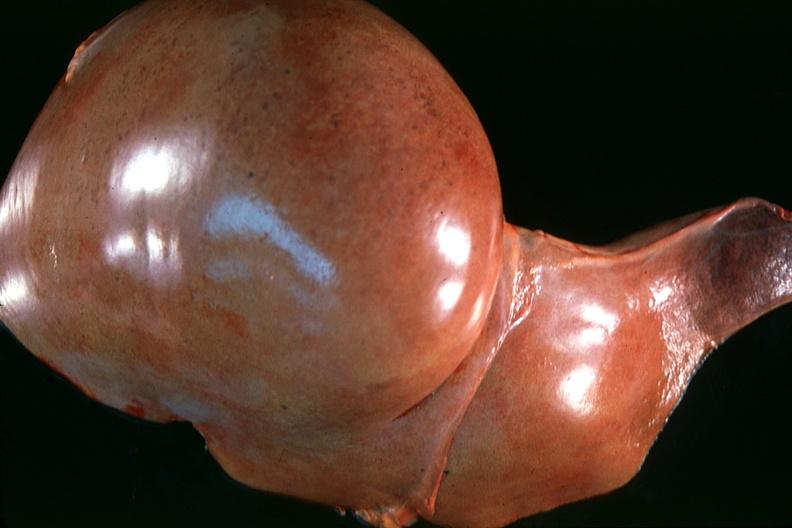s hepatobiliary present?
Answer the question using a single word or phrase. Yes 